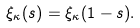Convert formula to latex. <formula><loc_0><loc_0><loc_500><loc_500>\xi _ { \kappa } ( s ) = \xi _ { \kappa } ( 1 - s ) .</formula> 